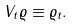Convert formula to latex. <formula><loc_0><loc_0><loc_500><loc_500>V _ { t } \varrho \equiv \varrho _ { t } .</formula> 